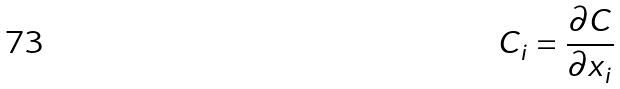Convert formula to latex. <formula><loc_0><loc_0><loc_500><loc_500>C _ { i } = \frac { \partial C } { \partial x _ { i } }</formula> 